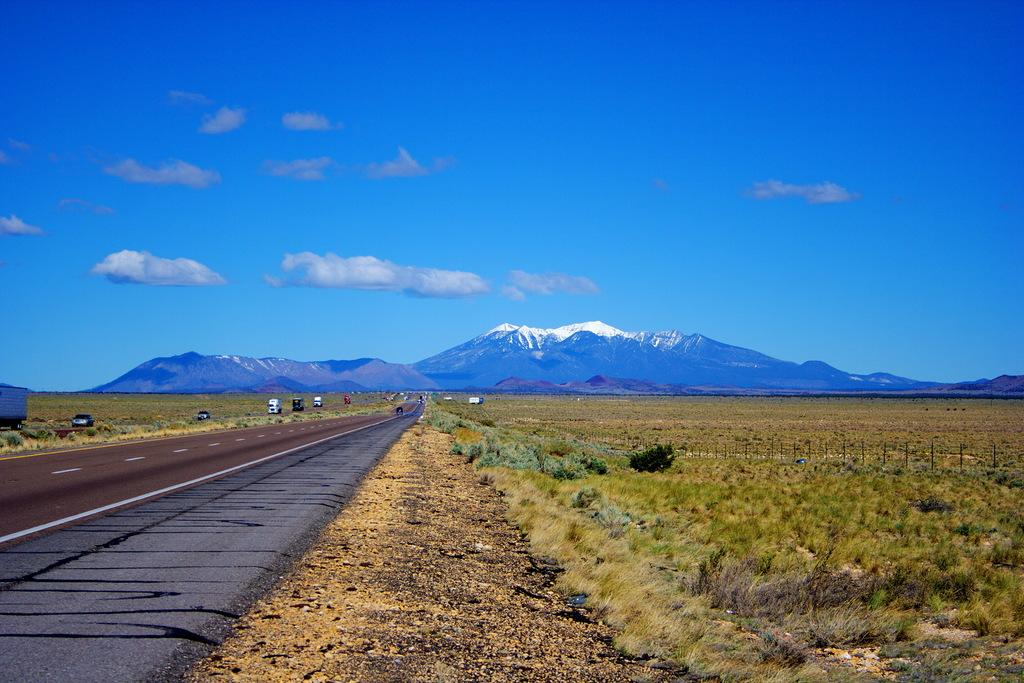What is the main feature of the image? There is a road in the image. What else can be seen on the road? There are vehicles in the image. What type of vegetation is present in the image? Grass and plants are visible in the image. What is the purpose of the fence in the image? The fence is likely used to separate or enclose an area. What is visible in the background of the image? Mountains and the sky are visible in the background of the image. What is the weather like in the image? The presence of clouds in the sky suggests that it might be partly cloudy. Where is the cemetery located in the image? There is no cemetery present in the image. Can you see any boats or docks near the mountains in the image? There is no mention of boats or docks in the image; it only features a road, vehicles, grass, plants, a fence, mountains, the sky, and clouds. 